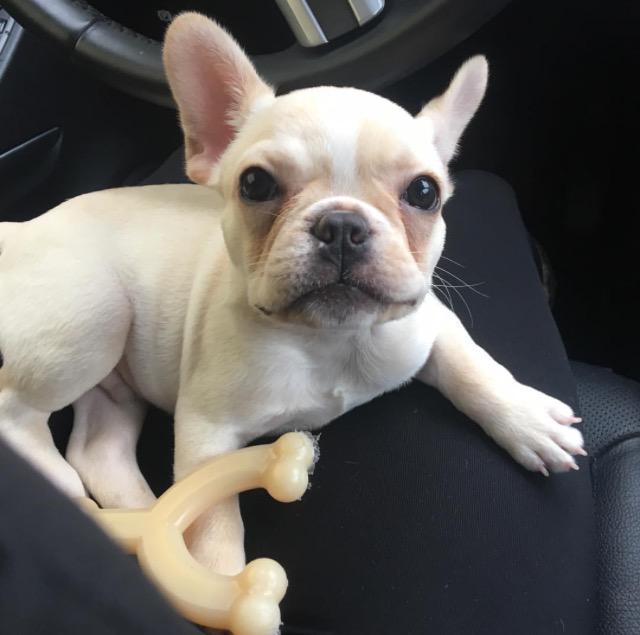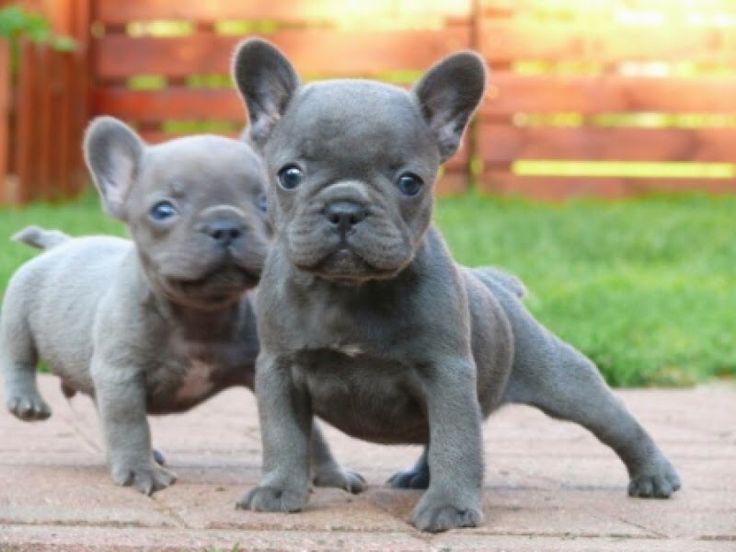The first image is the image on the left, the second image is the image on the right. Given the left and right images, does the statement "There are two puppies in the right image." hold true? Answer yes or no. Yes. The first image is the image on the left, the second image is the image on the right. For the images displayed, is the sentence "There are two black nose puppy bull dogs off leash looking forward." factually correct? Answer yes or no. Yes. 